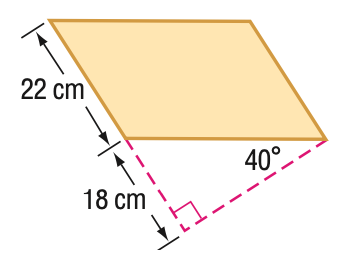Question: Find the area of the parallelogram. Round to the nearest tenth if necessary.
Choices:
A. 332.3
B. 396
C. 471.9
D. 616.1
Answer with the letter. Answer: C 